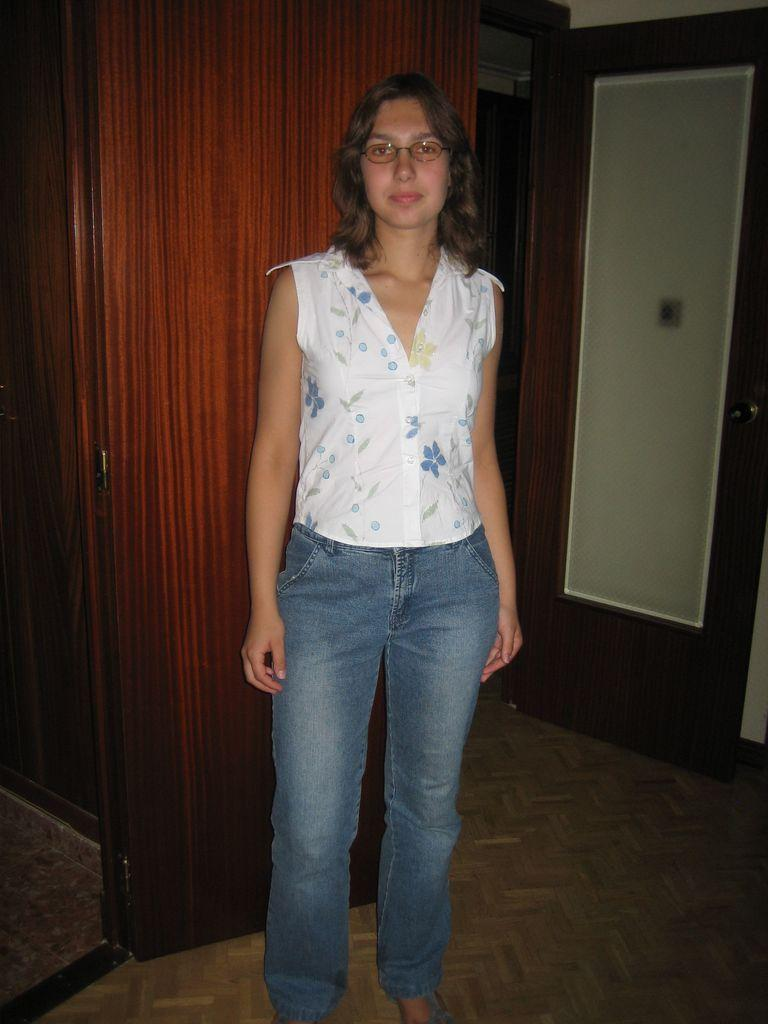What is the main subject of the image? There is a woman standing in the image. Can you describe the background of the image? There is a door visible in the background of the image. What is the woman's wrist doing in the image? There is no information about the woman's wrist in the image, so it cannot be determined what her wrist is doing. 